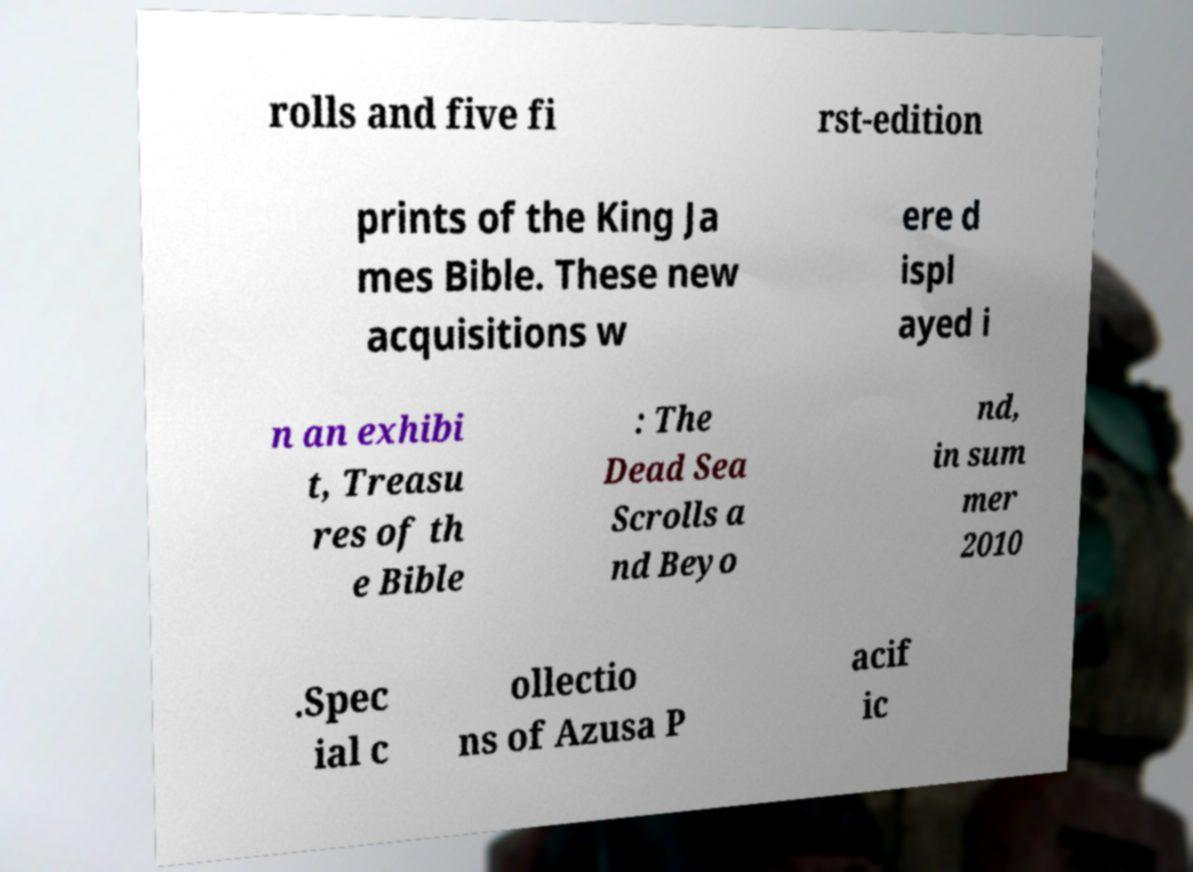Could you extract and type out the text from this image? rolls and five fi rst-edition prints of the King Ja mes Bible. These new acquisitions w ere d ispl ayed i n an exhibi t, Treasu res of th e Bible : The Dead Sea Scrolls a nd Beyo nd, in sum mer 2010 .Spec ial c ollectio ns of Azusa P acif ic 